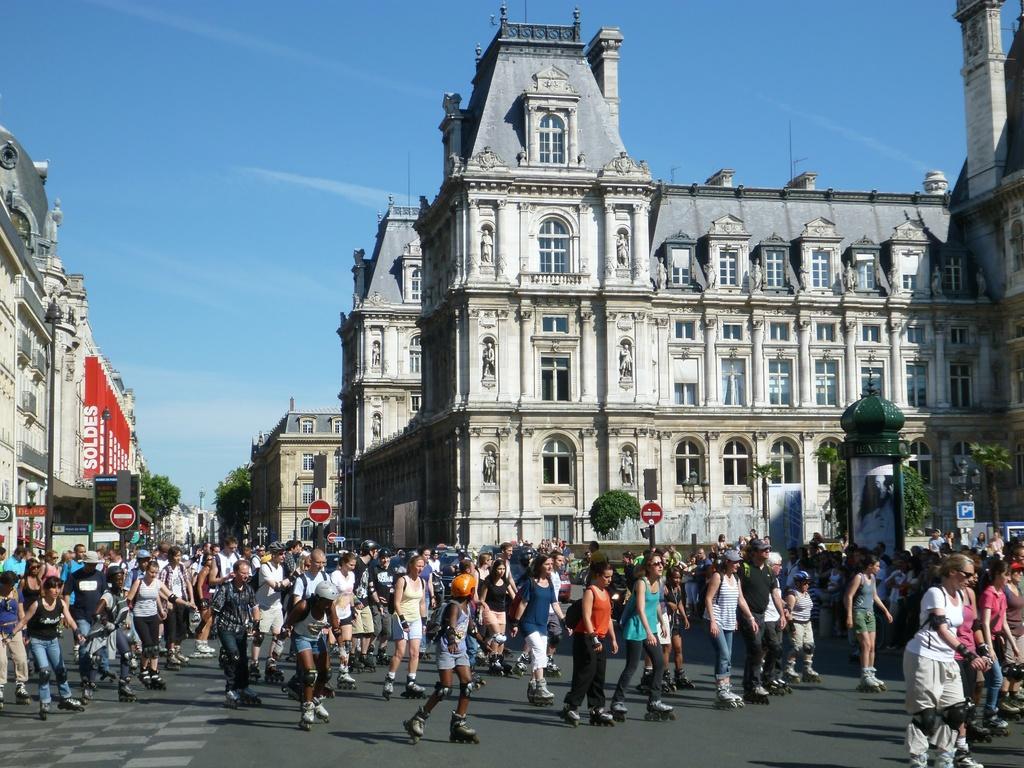Could you give a brief overview of what you see in this image? In this image we can see few buildings, sign boards, boards with some text written on it, there are a few people, some of them are skating on the road, also we can see the sky, trees. 